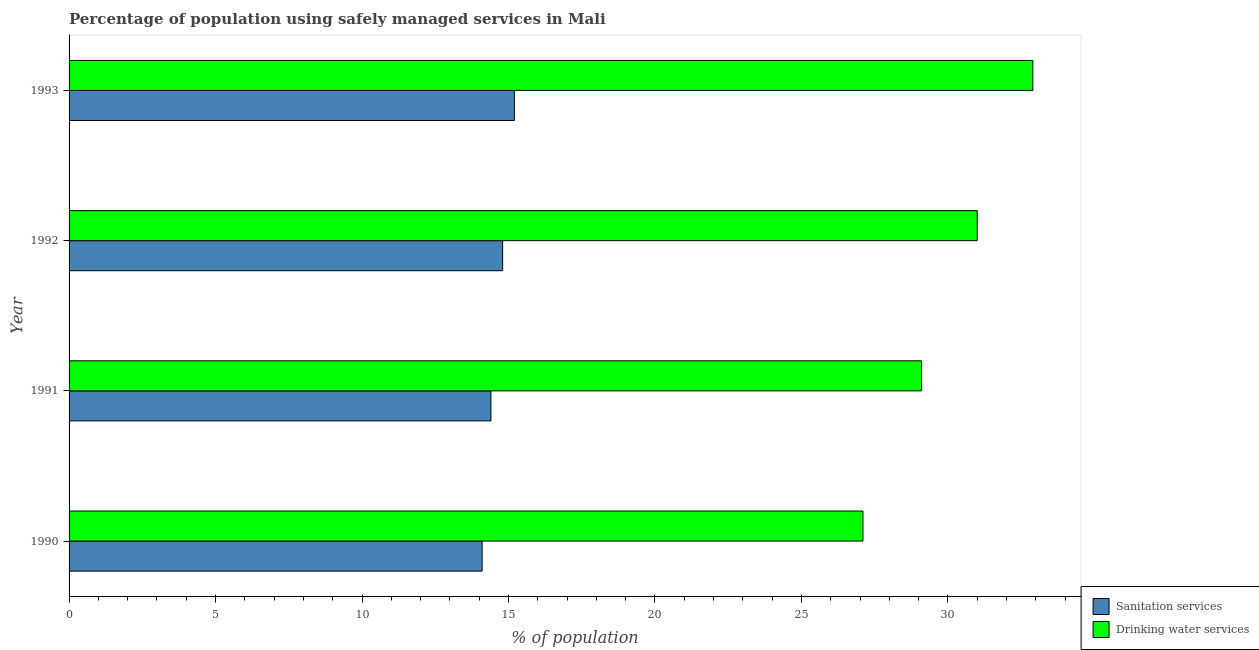How many bars are there on the 2nd tick from the top?
Your answer should be very brief. 2. How many bars are there on the 2nd tick from the bottom?
Provide a succinct answer. 2. What is the label of the 2nd group of bars from the top?
Make the answer very short. 1992. In how many cases, is the number of bars for a given year not equal to the number of legend labels?
Your response must be concise. 0. Across all years, what is the maximum percentage of population who used sanitation services?
Make the answer very short. 15.2. Across all years, what is the minimum percentage of population who used drinking water services?
Your answer should be compact. 27.1. In which year was the percentage of population who used sanitation services maximum?
Offer a terse response. 1993. In which year was the percentage of population who used sanitation services minimum?
Offer a terse response. 1990. What is the total percentage of population who used sanitation services in the graph?
Make the answer very short. 58.5. What is the average percentage of population who used sanitation services per year?
Offer a terse response. 14.62. In the year 1992, what is the difference between the percentage of population who used sanitation services and percentage of population who used drinking water services?
Keep it short and to the point. -16.2. In how many years, is the percentage of population who used drinking water services greater than 22 %?
Provide a short and direct response. 4. Is the percentage of population who used drinking water services in 1990 less than that in 1991?
Your answer should be very brief. Yes. Is the difference between the percentage of population who used drinking water services in 1990 and 1992 greater than the difference between the percentage of population who used sanitation services in 1990 and 1992?
Keep it short and to the point. No. In how many years, is the percentage of population who used drinking water services greater than the average percentage of population who used drinking water services taken over all years?
Keep it short and to the point. 2. What does the 1st bar from the top in 1993 represents?
Your answer should be compact. Drinking water services. What does the 2nd bar from the bottom in 1991 represents?
Ensure brevity in your answer.  Drinking water services. How many bars are there?
Your response must be concise. 8. Are all the bars in the graph horizontal?
Give a very brief answer. Yes. How many years are there in the graph?
Offer a very short reply. 4. How many legend labels are there?
Your response must be concise. 2. How are the legend labels stacked?
Keep it short and to the point. Vertical. What is the title of the graph?
Ensure brevity in your answer.  Percentage of population using safely managed services in Mali. What is the label or title of the X-axis?
Give a very brief answer. % of population. What is the % of population in Drinking water services in 1990?
Keep it short and to the point. 27.1. What is the % of population of Drinking water services in 1991?
Your response must be concise. 29.1. What is the % of population in Drinking water services in 1992?
Provide a short and direct response. 31. What is the % of population in Drinking water services in 1993?
Provide a short and direct response. 32.9. Across all years, what is the maximum % of population of Drinking water services?
Offer a terse response. 32.9. Across all years, what is the minimum % of population in Drinking water services?
Offer a terse response. 27.1. What is the total % of population in Sanitation services in the graph?
Provide a succinct answer. 58.5. What is the total % of population of Drinking water services in the graph?
Provide a succinct answer. 120.1. What is the difference between the % of population in Drinking water services in 1990 and that in 1991?
Your answer should be very brief. -2. What is the difference between the % of population of Sanitation services in 1990 and that in 1992?
Make the answer very short. -0.7. What is the difference between the % of population of Drinking water services in 1991 and that in 1992?
Offer a very short reply. -1.9. What is the difference between the % of population in Drinking water services in 1992 and that in 1993?
Provide a succinct answer. -1.9. What is the difference between the % of population of Sanitation services in 1990 and the % of population of Drinking water services in 1991?
Make the answer very short. -15. What is the difference between the % of population of Sanitation services in 1990 and the % of population of Drinking water services in 1992?
Give a very brief answer. -16.9. What is the difference between the % of population in Sanitation services in 1990 and the % of population in Drinking water services in 1993?
Ensure brevity in your answer.  -18.8. What is the difference between the % of population in Sanitation services in 1991 and the % of population in Drinking water services in 1992?
Ensure brevity in your answer.  -16.6. What is the difference between the % of population of Sanitation services in 1991 and the % of population of Drinking water services in 1993?
Your response must be concise. -18.5. What is the difference between the % of population of Sanitation services in 1992 and the % of population of Drinking water services in 1993?
Give a very brief answer. -18.1. What is the average % of population in Sanitation services per year?
Offer a terse response. 14.62. What is the average % of population in Drinking water services per year?
Your response must be concise. 30.02. In the year 1991, what is the difference between the % of population in Sanitation services and % of population in Drinking water services?
Your answer should be compact. -14.7. In the year 1992, what is the difference between the % of population of Sanitation services and % of population of Drinking water services?
Make the answer very short. -16.2. In the year 1993, what is the difference between the % of population in Sanitation services and % of population in Drinking water services?
Provide a short and direct response. -17.7. What is the ratio of the % of population of Sanitation services in 1990 to that in 1991?
Provide a short and direct response. 0.98. What is the ratio of the % of population in Drinking water services in 1990 to that in 1991?
Provide a succinct answer. 0.93. What is the ratio of the % of population of Sanitation services in 1990 to that in 1992?
Offer a terse response. 0.95. What is the ratio of the % of population in Drinking water services in 1990 to that in 1992?
Ensure brevity in your answer.  0.87. What is the ratio of the % of population in Sanitation services in 1990 to that in 1993?
Give a very brief answer. 0.93. What is the ratio of the % of population in Drinking water services in 1990 to that in 1993?
Make the answer very short. 0.82. What is the ratio of the % of population in Sanitation services in 1991 to that in 1992?
Ensure brevity in your answer.  0.97. What is the ratio of the % of population in Drinking water services in 1991 to that in 1992?
Your response must be concise. 0.94. What is the ratio of the % of population of Sanitation services in 1991 to that in 1993?
Offer a very short reply. 0.95. What is the ratio of the % of population of Drinking water services in 1991 to that in 1993?
Offer a very short reply. 0.88. What is the ratio of the % of population of Sanitation services in 1992 to that in 1993?
Your response must be concise. 0.97. What is the ratio of the % of population of Drinking water services in 1992 to that in 1993?
Keep it short and to the point. 0.94. What is the difference between the highest and the second highest % of population in Sanitation services?
Your answer should be very brief. 0.4. What is the difference between the highest and the second highest % of population of Drinking water services?
Provide a succinct answer. 1.9. What is the difference between the highest and the lowest % of population of Sanitation services?
Your response must be concise. 1.1. 